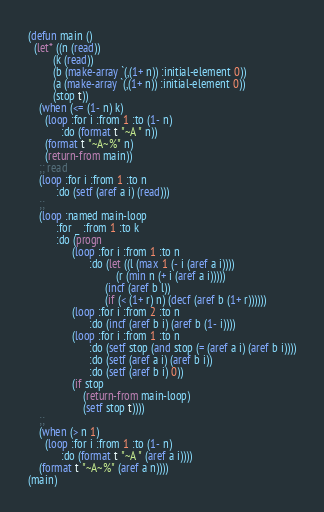Convert code to text. <code><loc_0><loc_0><loc_500><loc_500><_Lisp_>(defun main ()
  (let* ((n (read))
         (k (read))
         (b (make-array `(,(1+ n)) :initial-element 0))
         (a (make-array `(,(1+ n)) :initial-element 0))
         (stop t))
    (when (<= (1- n) k)
      (loop :for i :from 1 :to (1- n)
            :do (format t "~A " n))
      (format t "~A~%" n)
      (return-from main))
    ;; read 
    (loop :for i :from 1 :to n
          :do (setf (aref a i) (read)))
    ;;
    (loop :named main-loop
          :for _ :from 1 :to k
          :do (progn 
                (loop :for i :from 1 :to n
                      :do (let ((l (max 1 (- i (aref a i))))
                                (r (min n (+ i (aref a i)))))
                            (incf (aref b l))
                            (if (< (1+ r) n) (decf (aref b (1+ r))))))
                (loop :for i :from 2 :to n
                      :do (incf (aref b i) (aref b (1- i))))
                (loop :for i :from 1 :to n
                      :do (setf stop (and stop (= (aref a i) (aref b i))))
                      :do (setf (aref a i) (aref b i))
                      :do (setf (aref b i) 0))
                (if stop 
                    (return-from main-loop)
                    (setf stop t))))
    ;;
    (when (> n 1)
      (loop :for i :from 1 :to (1- n)
            :do (format t "~A " (aref a i))))
    (format t "~A~%" (aref a n))))
(main)
</code> 